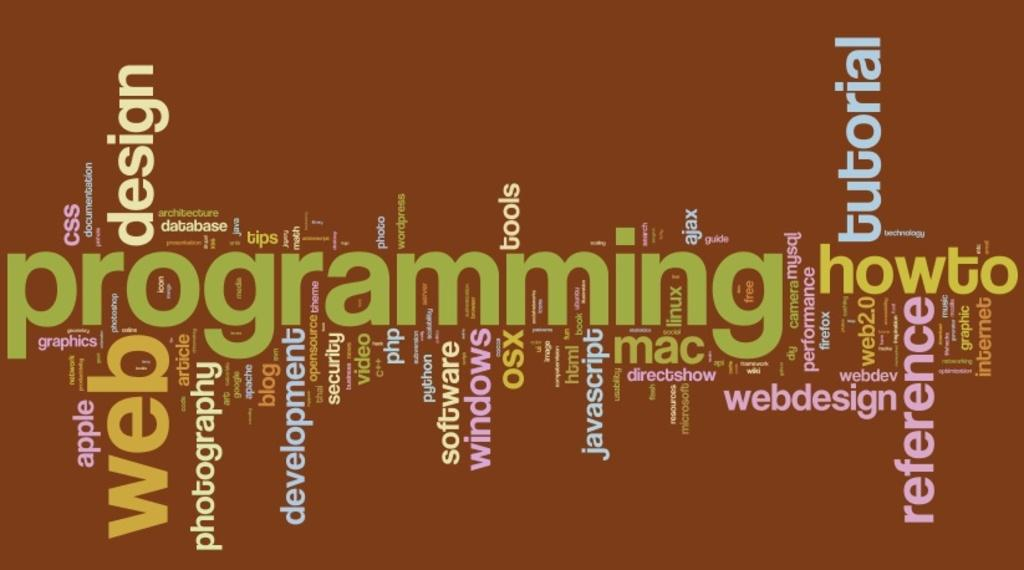Provide a one-sentence caption for the provided image. A word cloud features technology words like programming, javascript and web. 